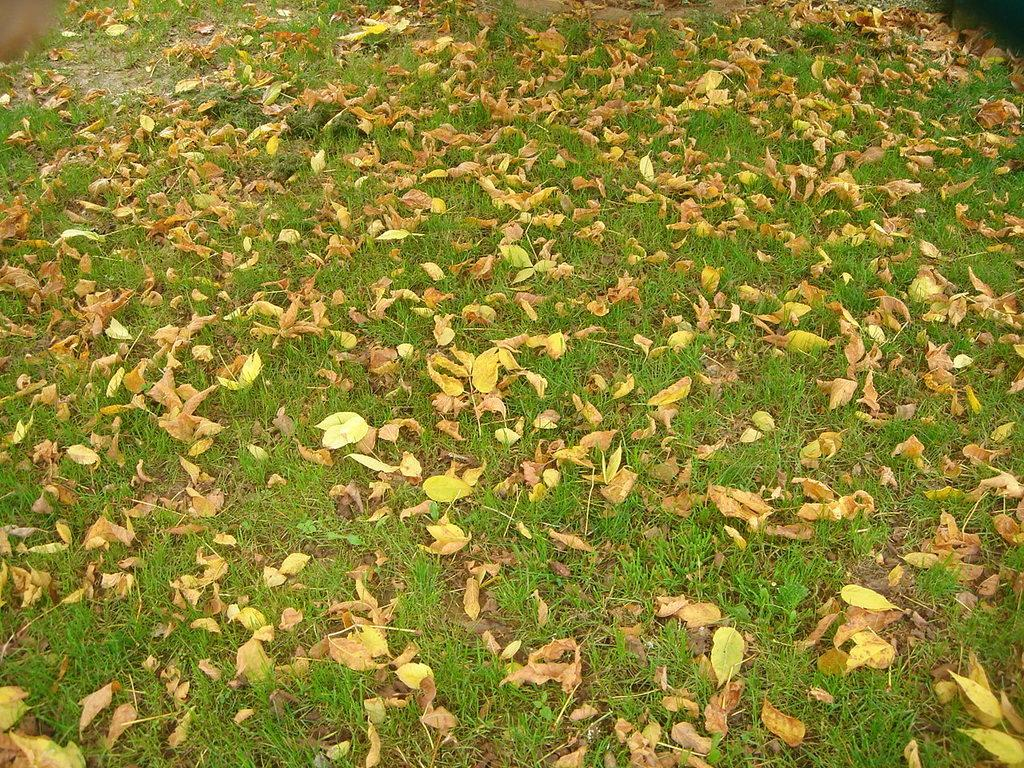What is covering the ground in the image? The ground in the image is covered with leaves. What type of dress is the bird wearing while reading the book in the image? There are no birds, books, or dresses present in the image; it only features a ground covered with leaves. 